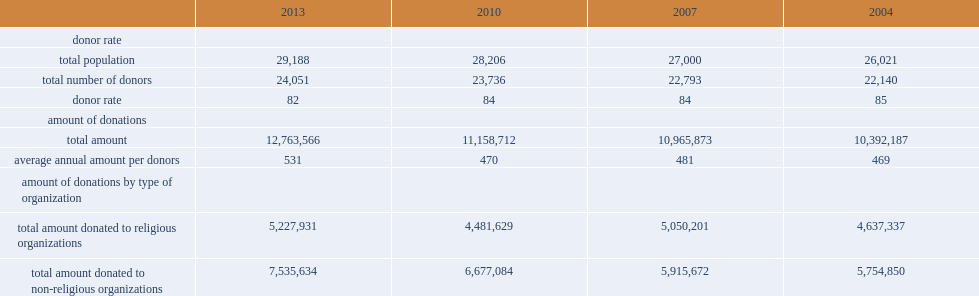What was the donor rate of canadians made financial donations to a charitable or non-profit organization in 2013? 82.0. How many percentge points decreased from 2010 to 2013 of people aged 15 and over who made a financial donation? 2. What was the total amount of donations by canadians to charitable or non-profit organizations increased between 2010 and 2013? 12763566.0. 